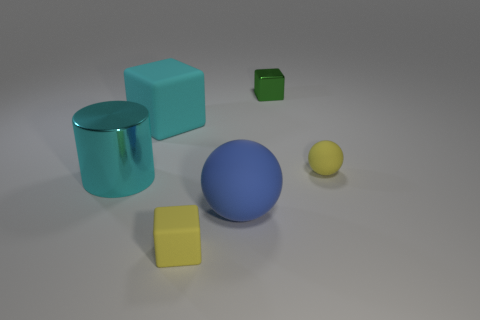Add 3 metal cubes. How many objects exist? 9 Subtract all cylinders. How many objects are left? 5 Add 6 brown matte things. How many brown matte things exist? 6 Subtract 0 red spheres. How many objects are left? 6 Subtract all purple rubber objects. Subtract all small yellow matte things. How many objects are left? 4 Add 5 green cubes. How many green cubes are left? 6 